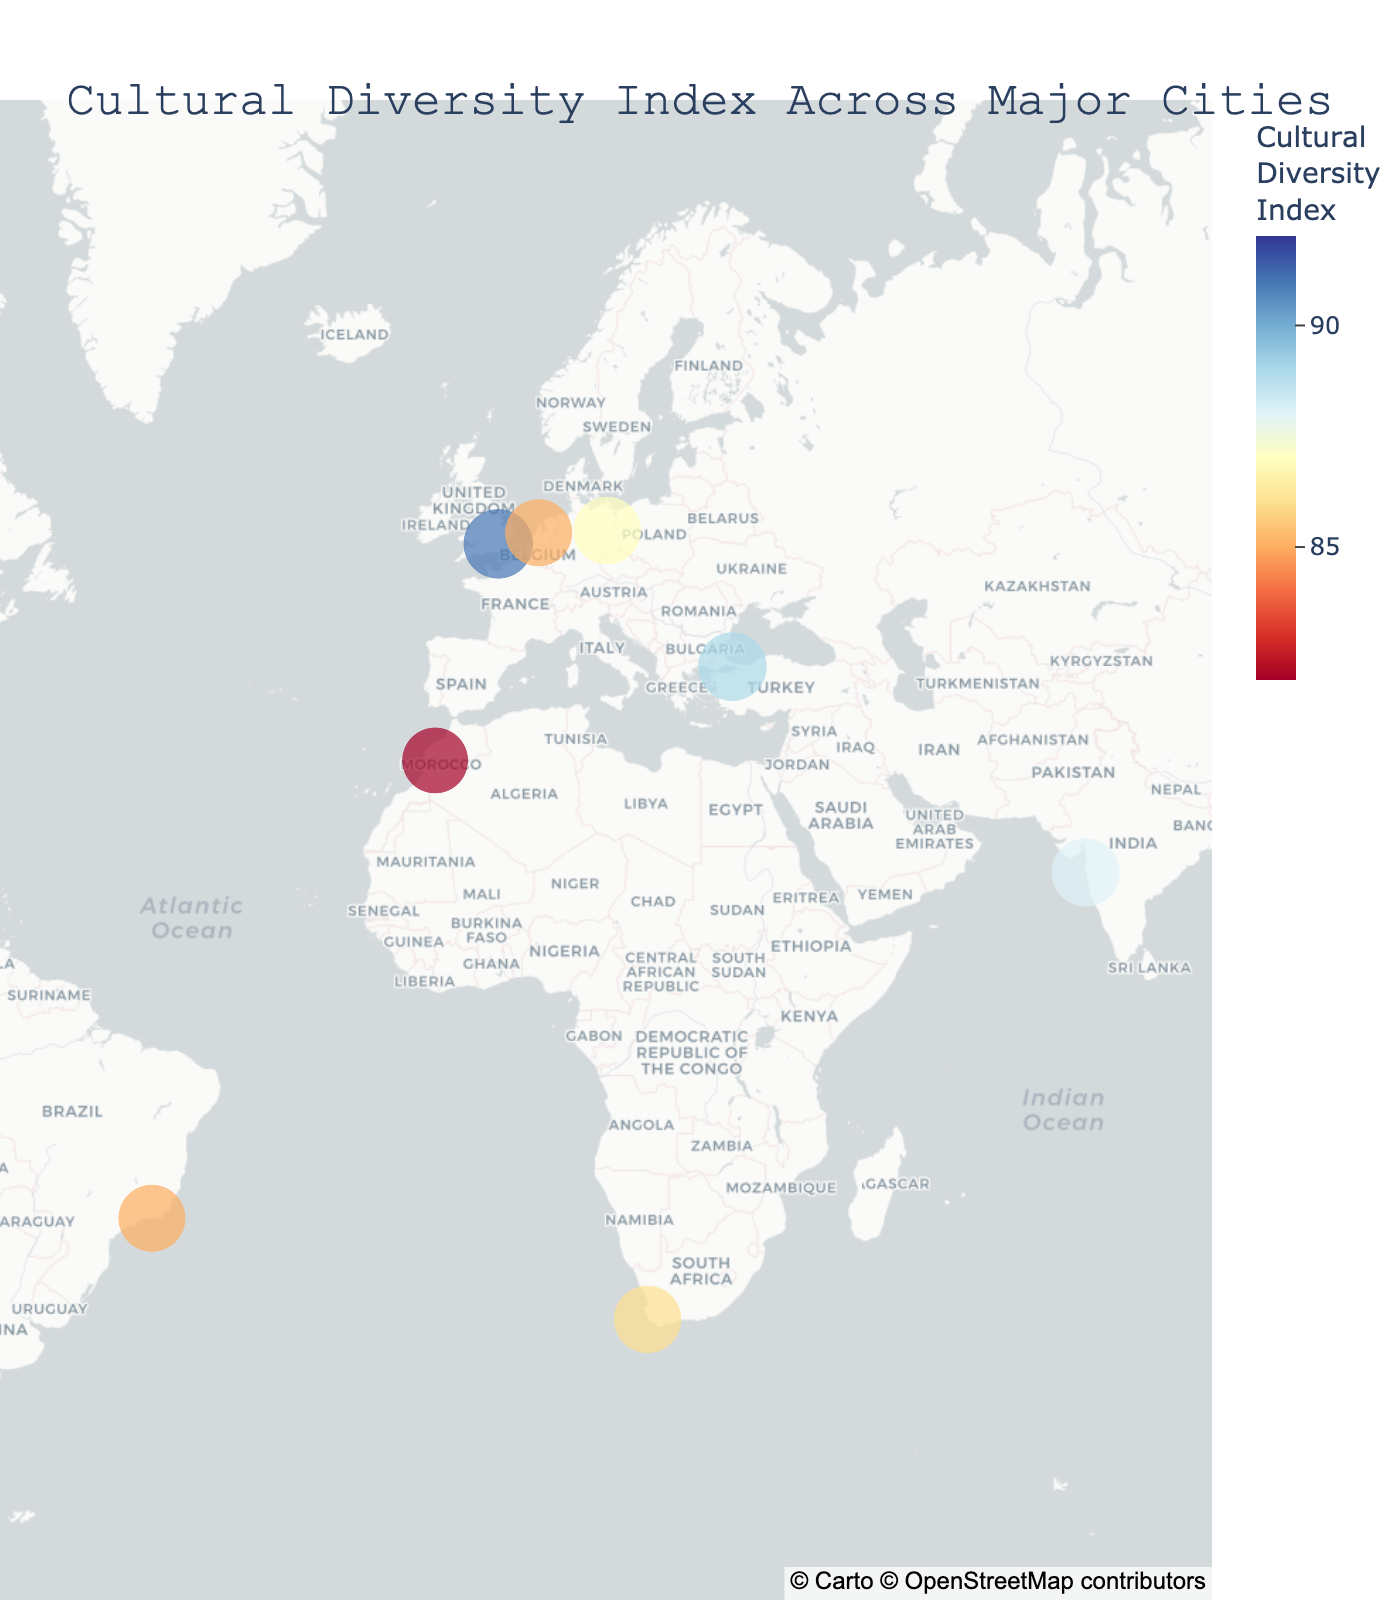Which city has the highest Cultural Diversity Index? The city with the highest Cultural Diversity Index can be identified by looking at the color legend and the size of the circle. The largest circle with the darkest blue color represents the city with the highest index.
Answer: New York City What's the average Cultural Diversity Index of all the cities? First, list out the Cultural Diversity Index values for all cities: (92, 88, 85, 89, 90, 87, 86, 91, 83, 88, 85, 87, 84, 82). Sum these values (1247) and then divide by the number of cities (14). So, the average is 1247/14 ≈ 89.07
Answer: 89.07 Which city in Asia has the highest Cultural Diversity Index? By comparing the Cultural Diversity Index values of the Asian cities (Mumbai, Tokyo, and Singapore), we see that Singapore has the highest value (90).
Answer: Singapore How does London’s Cultural Diversity Index compare to Istanbul’s? London's Cultural Diversity Index is 91, while Istanbul's is 89. Comparing these values, London has a higher index than Istanbul.
Answer: London has a higher index Which cities are in the Southern Hemisphere? Check the latitude values; cities with negative latitude are in the Southern Hemisphere. Rio de Janeiro (-22.9068), Sydney (-33.8688), and Cape Town (-33.9249) are the cities in the Southern Hemisphere.
Answer: Rio de Janeiro, Sydney, Cape Town Find the sum of Cultural Diversity Index values for cities in the Americas. List Cultural Diversity Index values for New York City (92), Rio de Janeiro (85), Mexico City (84), and Vancouver (88). Sum these values: 92 + 85 + 84 + 88 = 349
Answer: 349 Describe notable cultural elements for the city with the lowest Cultural Diversity Index. The city with the lowest Cultural Diversity Index is Marrakech, with a score of 82. The notable cultural elements include a blend of Berber and Arab cultural heritage.
Answer: Berber and Arab cultural blend Which city has more cultural diversity, Sydney or Berlin, and by how much? Sydney's Cultural Diversity Index is 87, and Berlin's is 87 as well. Both cities have the same index value, so the difference is 0.
Answer: Both have the same index; difference is 0 